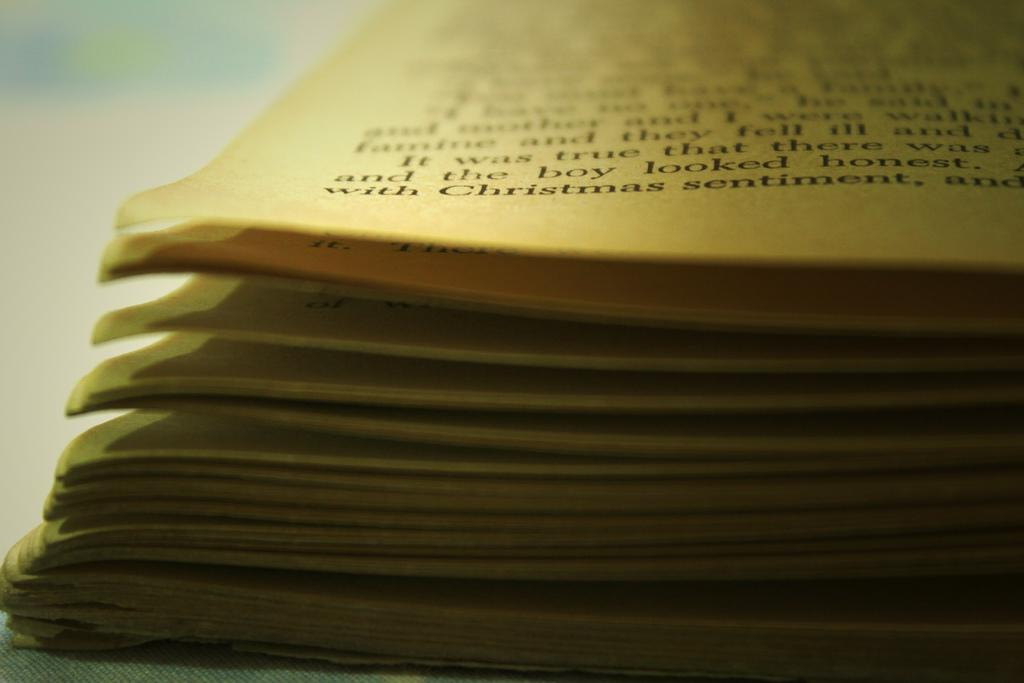<image>
Relay a brief, clear account of the picture shown. A book lays open with the word Christmas sentiment visible. 